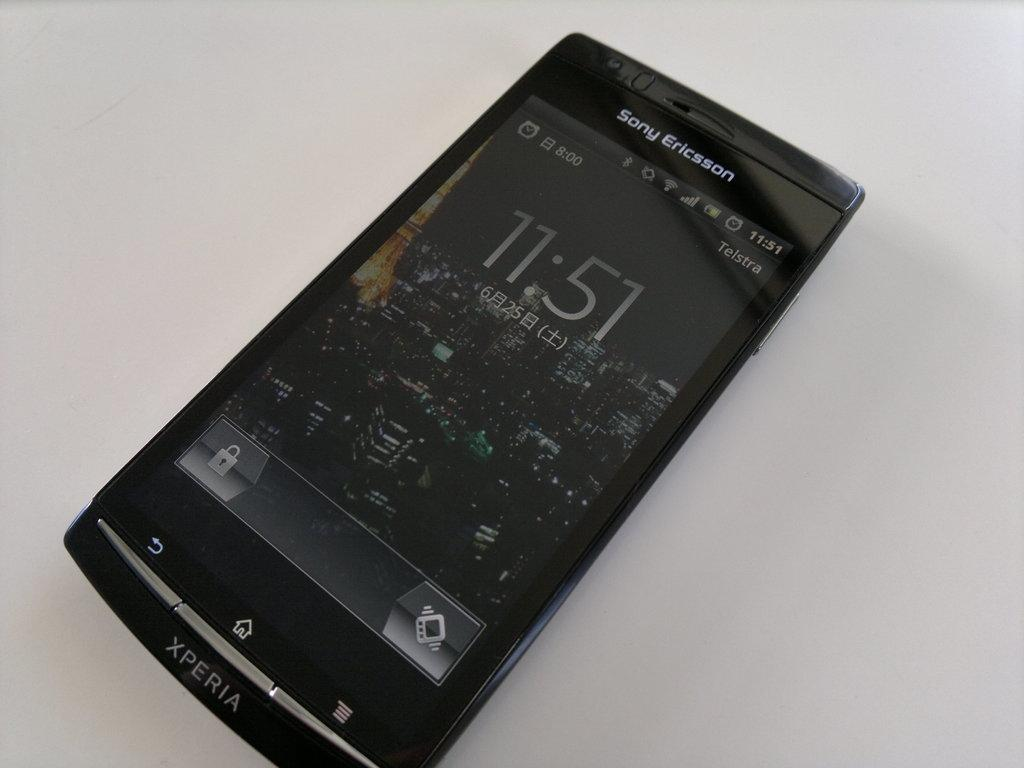Provide a one-sentence caption for the provided image. A home screen of a black Xperia Sony Ericsson phone. 